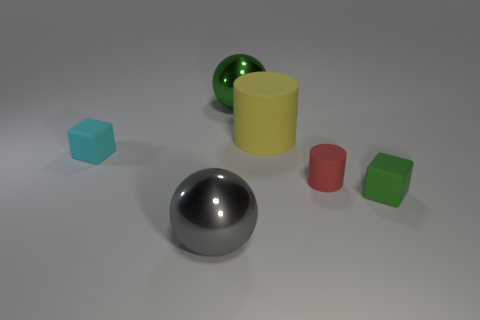Does the big thing that is in front of the cyan rubber cube have the same shape as the green thing behind the red object?
Make the answer very short. Yes. What color is the block that is the same size as the cyan matte thing?
Your answer should be compact. Green. What is the material of the sphere in front of the cube to the right of the ball that is behind the big gray metal thing?
Your response must be concise. Metal. Do the large matte object and the tiny block that is on the left side of the gray object have the same color?
Give a very brief answer. No. How many things are either matte blocks on the right side of the small red thing or tiny red rubber cylinders that are behind the green matte block?
Provide a succinct answer. 2. What is the shape of the big green shiny object behind the matte block to the left of the green block?
Your answer should be compact. Sphere. Are there any things that have the same material as the tiny cylinder?
Your answer should be very brief. Yes. What is the color of the other matte thing that is the same shape as the tiny green thing?
Your response must be concise. Cyan. Is the number of gray spheres in front of the tiny cyan thing less than the number of objects that are behind the green block?
Your answer should be compact. Yes. What number of other things are there of the same shape as the small green thing?
Offer a very short reply. 1. 